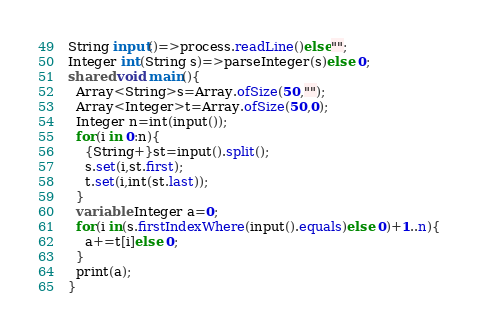<code> <loc_0><loc_0><loc_500><loc_500><_Ceylon_>String input()=>process.readLine()else""; 
Integer int(String s)=>parseInteger(s)else 0;
shared void main(){
  Array<String>s=Array.ofSize(50,"");
  Array<Integer>t=Array.ofSize(50,0);
  Integer n=int(input());
  for(i in 0:n){
    {String+}st=input().split();
    s.set(i,st.first);
    t.set(i,int(st.last));
  }
  variable Integer a=0;
  for(i in(s.firstIndexWhere(input().equals)else 0)+1..n){
    a+=t[i]else 0;
  }
  print(a);
}
</code> 